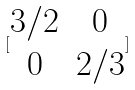Convert formula to latex. <formula><loc_0><loc_0><loc_500><loc_500>[ \begin{matrix} 3 / 2 & 0 \\ 0 & 2 / 3 \end{matrix} ]</formula> 